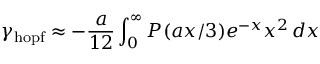Convert formula to latex. <formula><loc_0><loc_0><loc_500><loc_500>\gamma _ { h o p f } \approx - \frac { a } { 1 2 } \int _ { 0 } ^ { \infty } P ( a x / 3 ) e ^ { - x } x ^ { 2 } \, d x</formula> 